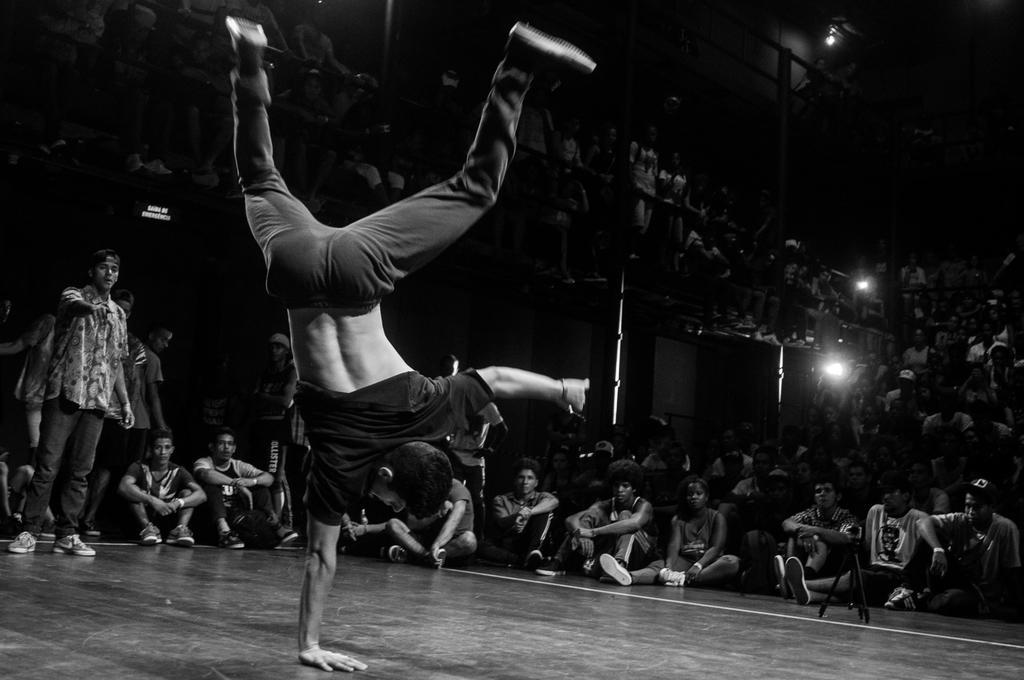How would you summarize this image in a sentence or two? I see this is a black and white image and I see number of people in which most of them are sitting and I see that this man is on his hand and I see the lights over here and I see that it is a bit dark in the background and I see the floor and I see the tripod over here. 